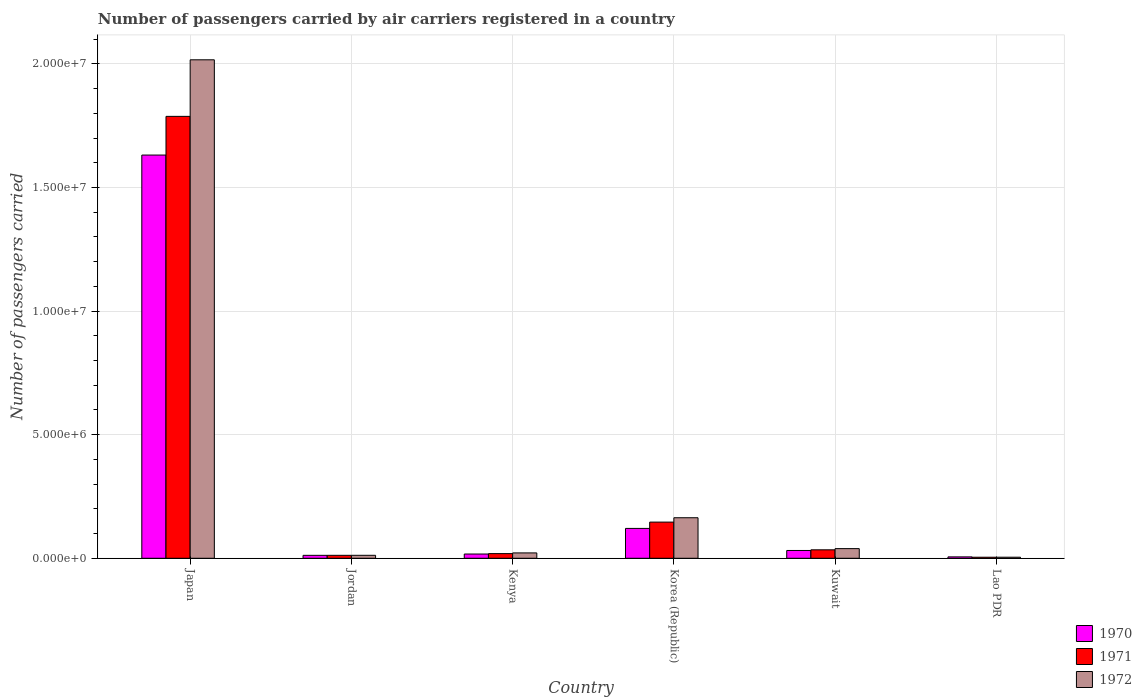How many different coloured bars are there?
Offer a very short reply. 3. How many groups of bars are there?
Provide a short and direct response. 6. Are the number of bars per tick equal to the number of legend labels?
Your response must be concise. Yes. How many bars are there on the 6th tick from the left?
Your answer should be very brief. 3. How many bars are there on the 2nd tick from the right?
Offer a terse response. 3. What is the label of the 4th group of bars from the left?
Ensure brevity in your answer.  Korea (Republic). What is the number of passengers carried by air carriers in 1971 in Lao PDR?
Your answer should be compact. 4.20e+04. Across all countries, what is the maximum number of passengers carried by air carriers in 1971?
Your answer should be compact. 1.79e+07. Across all countries, what is the minimum number of passengers carried by air carriers in 1972?
Make the answer very short. 4.30e+04. In which country was the number of passengers carried by air carriers in 1971 minimum?
Your answer should be very brief. Lao PDR. What is the total number of passengers carried by air carriers in 1972 in the graph?
Offer a terse response. 2.26e+07. What is the difference between the number of passengers carried by air carriers in 1971 in Kenya and that in Kuwait?
Make the answer very short. -1.54e+05. What is the difference between the number of passengers carried by air carriers in 1972 in Jordan and the number of passengers carried by air carriers in 1970 in Korea (Republic)?
Offer a terse response. -1.09e+06. What is the average number of passengers carried by air carriers in 1970 per country?
Provide a short and direct response. 3.03e+06. What is the difference between the number of passengers carried by air carriers of/in 1971 and number of passengers carried by air carriers of/in 1972 in Jordan?
Keep it short and to the point. -300. What is the ratio of the number of passengers carried by air carriers in 1971 in Jordan to that in Kuwait?
Keep it short and to the point. 0.35. What is the difference between the highest and the second highest number of passengers carried by air carriers in 1972?
Offer a terse response. -1.85e+07. What is the difference between the highest and the lowest number of passengers carried by air carriers in 1970?
Ensure brevity in your answer.  1.63e+07. In how many countries, is the number of passengers carried by air carriers in 1970 greater than the average number of passengers carried by air carriers in 1970 taken over all countries?
Give a very brief answer. 1. What does the 3rd bar from the left in Korea (Republic) represents?
Provide a succinct answer. 1972. What does the 2nd bar from the right in Japan represents?
Your response must be concise. 1971. Is it the case that in every country, the sum of the number of passengers carried by air carriers in 1970 and number of passengers carried by air carriers in 1972 is greater than the number of passengers carried by air carriers in 1971?
Offer a very short reply. Yes. Are all the bars in the graph horizontal?
Ensure brevity in your answer.  No. How many countries are there in the graph?
Provide a succinct answer. 6. What is the difference between two consecutive major ticks on the Y-axis?
Provide a short and direct response. 5.00e+06. Are the values on the major ticks of Y-axis written in scientific E-notation?
Offer a very short reply. Yes. Does the graph contain grids?
Make the answer very short. Yes. Where does the legend appear in the graph?
Your answer should be very brief. Bottom right. How many legend labels are there?
Offer a very short reply. 3. What is the title of the graph?
Your response must be concise. Number of passengers carried by air carriers registered in a country. What is the label or title of the X-axis?
Offer a terse response. Country. What is the label or title of the Y-axis?
Give a very brief answer. Number of passengers carried. What is the Number of passengers carried in 1970 in Japan?
Give a very brief answer. 1.63e+07. What is the Number of passengers carried of 1971 in Japan?
Keep it short and to the point. 1.79e+07. What is the Number of passengers carried in 1972 in Japan?
Offer a terse response. 2.02e+07. What is the Number of passengers carried in 1970 in Jordan?
Make the answer very short. 1.19e+05. What is the Number of passengers carried in 1971 in Jordan?
Your answer should be very brief. 1.20e+05. What is the Number of passengers carried of 1972 in Jordan?
Offer a terse response. 1.20e+05. What is the Number of passengers carried in 1970 in Kenya?
Offer a very short reply. 1.72e+05. What is the Number of passengers carried in 1971 in Kenya?
Offer a very short reply. 1.88e+05. What is the Number of passengers carried in 1972 in Kenya?
Your answer should be compact. 2.17e+05. What is the Number of passengers carried of 1970 in Korea (Republic)?
Give a very brief answer. 1.21e+06. What is the Number of passengers carried of 1971 in Korea (Republic)?
Ensure brevity in your answer.  1.46e+06. What is the Number of passengers carried in 1972 in Korea (Republic)?
Ensure brevity in your answer.  1.64e+06. What is the Number of passengers carried of 1970 in Kuwait?
Give a very brief answer. 3.15e+05. What is the Number of passengers carried of 1971 in Kuwait?
Your answer should be compact. 3.42e+05. What is the Number of passengers carried of 1972 in Kuwait?
Offer a terse response. 3.91e+05. What is the Number of passengers carried in 1970 in Lao PDR?
Give a very brief answer. 5.59e+04. What is the Number of passengers carried in 1971 in Lao PDR?
Provide a short and direct response. 4.20e+04. What is the Number of passengers carried of 1972 in Lao PDR?
Give a very brief answer. 4.30e+04. Across all countries, what is the maximum Number of passengers carried of 1970?
Provide a short and direct response. 1.63e+07. Across all countries, what is the maximum Number of passengers carried in 1971?
Ensure brevity in your answer.  1.79e+07. Across all countries, what is the maximum Number of passengers carried in 1972?
Offer a terse response. 2.02e+07. Across all countries, what is the minimum Number of passengers carried of 1970?
Provide a short and direct response. 5.59e+04. Across all countries, what is the minimum Number of passengers carried of 1971?
Provide a succinct answer. 4.20e+04. Across all countries, what is the minimum Number of passengers carried in 1972?
Offer a terse response. 4.30e+04. What is the total Number of passengers carried in 1970 in the graph?
Provide a succinct answer. 1.82e+07. What is the total Number of passengers carried in 1971 in the graph?
Offer a very short reply. 2.00e+07. What is the total Number of passengers carried in 1972 in the graph?
Ensure brevity in your answer.  2.26e+07. What is the difference between the Number of passengers carried of 1970 in Japan and that in Jordan?
Provide a succinct answer. 1.62e+07. What is the difference between the Number of passengers carried of 1971 in Japan and that in Jordan?
Give a very brief answer. 1.78e+07. What is the difference between the Number of passengers carried in 1972 in Japan and that in Jordan?
Ensure brevity in your answer.  2.00e+07. What is the difference between the Number of passengers carried in 1970 in Japan and that in Kenya?
Give a very brief answer. 1.61e+07. What is the difference between the Number of passengers carried of 1971 in Japan and that in Kenya?
Your answer should be compact. 1.77e+07. What is the difference between the Number of passengers carried in 1972 in Japan and that in Kenya?
Ensure brevity in your answer.  2.00e+07. What is the difference between the Number of passengers carried of 1970 in Japan and that in Korea (Republic)?
Make the answer very short. 1.51e+07. What is the difference between the Number of passengers carried in 1971 in Japan and that in Korea (Republic)?
Your answer should be very brief. 1.64e+07. What is the difference between the Number of passengers carried in 1972 in Japan and that in Korea (Republic)?
Make the answer very short. 1.85e+07. What is the difference between the Number of passengers carried of 1970 in Japan and that in Kuwait?
Offer a terse response. 1.60e+07. What is the difference between the Number of passengers carried in 1971 in Japan and that in Kuwait?
Give a very brief answer. 1.75e+07. What is the difference between the Number of passengers carried in 1972 in Japan and that in Kuwait?
Offer a terse response. 1.98e+07. What is the difference between the Number of passengers carried in 1970 in Japan and that in Lao PDR?
Offer a terse response. 1.63e+07. What is the difference between the Number of passengers carried of 1971 in Japan and that in Lao PDR?
Your answer should be very brief. 1.78e+07. What is the difference between the Number of passengers carried in 1972 in Japan and that in Lao PDR?
Your answer should be very brief. 2.01e+07. What is the difference between the Number of passengers carried in 1970 in Jordan and that in Kenya?
Give a very brief answer. -5.27e+04. What is the difference between the Number of passengers carried of 1971 in Jordan and that in Kenya?
Your response must be concise. -6.84e+04. What is the difference between the Number of passengers carried of 1972 in Jordan and that in Kenya?
Your answer should be very brief. -9.69e+04. What is the difference between the Number of passengers carried of 1970 in Jordan and that in Korea (Republic)?
Provide a succinct answer. -1.09e+06. What is the difference between the Number of passengers carried in 1971 in Jordan and that in Korea (Republic)?
Keep it short and to the point. -1.34e+06. What is the difference between the Number of passengers carried in 1972 in Jordan and that in Korea (Republic)?
Provide a succinct answer. -1.52e+06. What is the difference between the Number of passengers carried in 1970 in Jordan and that in Kuwait?
Your answer should be very brief. -1.96e+05. What is the difference between the Number of passengers carried of 1971 in Jordan and that in Kuwait?
Offer a very short reply. -2.23e+05. What is the difference between the Number of passengers carried of 1972 in Jordan and that in Kuwait?
Give a very brief answer. -2.71e+05. What is the difference between the Number of passengers carried of 1970 in Jordan and that in Lao PDR?
Keep it short and to the point. 6.29e+04. What is the difference between the Number of passengers carried in 1971 in Jordan and that in Lao PDR?
Offer a terse response. 7.76e+04. What is the difference between the Number of passengers carried in 1972 in Jordan and that in Lao PDR?
Ensure brevity in your answer.  7.69e+04. What is the difference between the Number of passengers carried of 1970 in Kenya and that in Korea (Republic)?
Your answer should be compact. -1.04e+06. What is the difference between the Number of passengers carried in 1971 in Kenya and that in Korea (Republic)?
Keep it short and to the point. -1.28e+06. What is the difference between the Number of passengers carried in 1972 in Kenya and that in Korea (Republic)?
Provide a short and direct response. -1.42e+06. What is the difference between the Number of passengers carried in 1970 in Kenya and that in Kuwait?
Keep it short and to the point. -1.44e+05. What is the difference between the Number of passengers carried in 1971 in Kenya and that in Kuwait?
Keep it short and to the point. -1.54e+05. What is the difference between the Number of passengers carried of 1972 in Kenya and that in Kuwait?
Ensure brevity in your answer.  -1.74e+05. What is the difference between the Number of passengers carried of 1970 in Kenya and that in Lao PDR?
Give a very brief answer. 1.16e+05. What is the difference between the Number of passengers carried in 1971 in Kenya and that in Lao PDR?
Offer a very short reply. 1.46e+05. What is the difference between the Number of passengers carried in 1972 in Kenya and that in Lao PDR?
Your answer should be compact. 1.74e+05. What is the difference between the Number of passengers carried of 1970 in Korea (Republic) and that in Kuwait?
Provide a succinct answer. 8.93e+05. What is the difference between the Number of passengers carried of 1971 in Korea (Republic) and that in Kuwait?
Make the answer very short. 1.12e+06. What is the difference between the Number of passengers carried of 1972 in Korea (Republic) and that in Kuwait?
Give a very brief answer. 1.25e+06. What is the difference between the Number of passengers carried in 1970 in Korea (Republic) and that in Lao PDR?
Your answer should be very brief. 1.15e+06. What is the difference between the Number of passengers carried of 1971 in Korea (Republic) and that in Lao PDR?
Provide a short and direct response. 1.42e+06. What is the difference between the Number of passengers carried of 1972 in Korea (Republic) and that in Lao PDR?
Your response must be concise. 1.60e+06. What is the difference between the Number of passengers carried of 1970 in Kuwait and that in Lao PDR?
Offer a terse response. 2.59e+05. What is the difference between the Number of passengers carried of 1971 in Kuwait and that in Lao PDR?
Keep it short and to the point. 3.00e+05. What is the difference between the Number of passengers carried of 1972 in Kuwait and that in Lao PDR?
Your answer should be very brief. 3.48e+05. What is the difference between the Number of passengers carried in 1970 in Japan and the Number of passengers carried in 1971 in Jordan?
Your answer should be very brief. 1.62e+07. What is the difference between the Number of passengers carried in 1970 in Japan and the Number of passengers carried in 1972 in Jordan?
Provide a succinct answer. 1.62e+07. What is the difference between the Number of passengers carried in 1971 in Japan and the Number of passengers carried in 1972 in Jordan?
Your answer should be compact. 1.78e+07. What is the difference between the Number of passengers carried of 1970 in Japan and the Number of passengers carried of 1971 in Kenya?
Ensure brevity in your answer.  1.61e+07. What is the difference between the Number of passengers carried in 1970 in Japan and the Number of passengers carried in 1972 in Kenya?
Provide a short and direct response. 1.61e+07. What is the difference between the Number of passengers carried of 1971 in Japan and the Number of passengers carried of 1972 in Kenya?
Your answer should be very brief. 1.77e+07. What is the difference between the Number of passengers carried in 1970 in Japan and the Number of passengers carried in 1971 in Korea (Republic)?
Keep it short and to the point. 1.49e+07. What is the difference between the Number of passengers carried of 1970 in Japan and the Number of passengers carried of 1972 in Korea (Republic)?
Offer a terse response. 1.47e+07. What is the difference between the Number of passengers carried in 1971 in Japan and the Number of passengers carried in 1972 in Korea (Republic)?
Offer a very short reply. 1.62e+07. What is the difference between the Number of passengers carried in 1970 in Japan and the Number of passengers carried in 1971 in Kuwait?
Provide a succinct answer. 1.60e+07. What is the difference between the Number of passengers carried of 1970 in Japan and the Number of passengers carried of 1972 in Kuwait?
Your answer should be very brief. 1.59e+07. What is the difference between the Number of passengers carried in 1971 in Japan and the Number of passengers carried in 1972 in Kuwait?
Your response must be concise. 1.75e+07. What is the difference between the Number of passengers carried of 1970 in Japan and the Number of passengers carried of 1971 in Lao PDR?
Your answer should be very brief. 1.63e+07. What is the difference between the Number of passengers carried in 1970 in Japan and the Number of passengers carried in 1972 in Lao PDR?
Your answer should be very brief. 1.63e+07. What is the difference between the Number of passengers carried of 1971 in Japan and the Number of passengers carried of 1972 in Lao PDR?
Keep it short and to the point. 1.78e+07. What is the difference between the Number of passengers carried of 1970 in Jordan and the Number of passengers carried of 1971 in Kenya?
Provide a short and direct response. -6.92e+04. What is the difference between the Number of passengers carried in 1970 in Jordan and the Number of passengers carried in 1972 in Kenya?
Your response must be concise. -9.80e+04. What is the difference between the Number of passengers carried in 1971 in Jordan and the Number of passengers carried in 1972 in Kenya?
Provide a short and direct response. -9.72e+04. What is the difference between the Number of passengers carried in 1970 in Jordan and the Number of passengers carried in 1971 in Korea (Republic)?
Give a very brief answer. -1.34e+06. What is the difference between the Number of passengers carried in 1970 in Jordan and the Number of passengers carried in 1972 in Korea (Republic)?
Make the answer very short. -1.52e+06. What is the difference between the Number of passengers carried of 1971 in Jordan and the Number of passengers carried of 1972 in Korea (Republic)?
Make the answer very short. -1.52e+06. What is the difference between the Number of passengers carried of 1970 in Jordan and the Number of passengers carried of 1971 in Kuwait?
Ensure brevity in your answer.  -2.23e+05. What is the difference between the Number of passengers carried in 1970 in Jordan and the Number of passengers carried in 1972 in Kuwait?
Provide a succinct answer. -2.72e+05. What is the difference between the Number of passengers carried in 1971 in Jordan and the Number of passengers carried in 1972 in Kuwait?
Your response must be concise. -2.71e+05. What is the difference between the Number of passengers carried of 1970 in Jordan and the Number of passengers carried of 1971 in Lao PDR?
Keep it short and to the point. 7.68e+04. What is the difference between the Number of passengers carried in 1970 in Jordan and the Number of passengers carried in 1972 in Lao PDR?
Provide a short and direct response. 7.58e+04. What is the difference between the Number of passengers carried of 1971 in Jordan and the Number of passengers carried of 1972 in Lao PDR?
Provide a short and direct response. 7.66e+04. What is the difference between the Number of passengers carried of 1970 in Kenya and the Number of passengers carried of 1971 in Korea (Republic)?
Offer a terse response. -1.29e+06. What is the difference between the Number of passengers carried in 1970 in Kenya and the Number of passengers carried in 1972 in Korea (Republic)?
Provide a succinct answer. -1.47e+06. What is the difference between the Number of passengers carried in 1971 in Kenya and the Number of passengers carried in 1972 in Korea (Republic)?
Provide a short and direct response. -1.45e+06. What is the difference between the Number of passengers carried of 1970 in Kenya and the Number of passengers carried of 1971 in Kuwait?
Make the answer very short. -1.71e+05. What is the difference between the Number of passengers carried in 1970 in Kenya and the Number of passengers carried in 1972 in Kuwait?
Make the answer very short. -2.19e+05. What is the difference between the Number of passengers carried of 1971 in Kenya and the Number of passengers carried of 1972 in Kuwait?
Give a very brief answer. -2.03e+05. What is the difference between the Number of passengers carried in 1970 in Kenya and the Number of passengers carried in 1971 in Lao PDR?
Provide a short and direct response. 1.30e+05. What is the difference between the Number of passengers carried in 1970 in Kenya and the Number of passengers carried in 1972 in Lao PDR?
Provide a succinct answer. 1.28e+05. What is the difference between the Number of passengers carried of 1971 in Kenya and the Number of passengers carried of 1972 in Lao PDR?
Provide a short and direct response. 1.45e+05. What is the difference between the Number of passengers carried in 1970 in Korea (Republic) and the Number of passengers carried in 1971 in Kuwait?
Offer a very short reply. 8.66e+05. What is the difference between the Number of passengers carried in 1970 in Korea (Republic) and the Number of passengers carried in 1972 in Kuwait?
Your response must be concise. 8.17e+05. What is the difference between the Number of passengers carried in 1971 in Korea (Republic) and the Number of passengers carried in 1972 in Kuwait?
Offer a terse response. 1.07e+06. What is the difference between the Number of passengers carried in 1970 in Korea (Republic) and the Number of passengers carried in 1971 in Lao PDR?
Your answer should be compact. 1.17e+06. What is the difference between the Number of passengers carried in 1970 in Korea (Republic) and the Number of passengers carried in 1972 in Lao PDR?
Keep it short and to the point. 1.17e+06. What is the difference between the Number of passengers carried of 1971 in Korea (Republic) and the Number of passengers carried of 1972 in Lao PDR?
Keep it short and to the point. 1.42e+06. What is the difference between the Number of passengers carried of 1970 in Kuwait and the Number of passengers carried of 1971 in Lao PDR?
Make the answer very short. 2.73e+05. What is the difference between the Number of passengers carried of 1970 in Kuwait and the Number of passengers carried of 1972 in Lao PDR?
Provide a succinct answer. 2.72e+05. What is the difference between the Number of passengers carried in 1971 in Kuwait and the Number of passengers carried in 1972 in Lao PDR?
Provide a short and direct response. 2.99e+05. What is the average Number of passengers carried of 1970 per country?
Offer a terse response. 3.03e+06. What is the average Number of passengers carried of 1971 per country?
Provide a succinct answer. 3.34e+06. What is the average Number of passengers carried of 1972 per country?
Your answer should be compact. 3.76e+06. What is the difference between the Number of passengers carried in 1970 and Number of passengers carried in 1971 in Japan?
Provide a succinct answer. -1.57e+06. What is the difference between the Number of passengers carried in 1970 and Number of passengers carried in 1972 in Japan?
Keep it short and to the point. -3.85e+06. What is the difference between the Number of passengers carried of 1971 and Number of passengers carried of 1972 in Japan?
Your answer should be compact. -2.29e+06. What is the difference between the Number of passengers carried in 1970 and Number of passengers carried in 1971 in Jordan?
Give a very brief answer. -800. What is the difference between the Number of passengers carried in 1970 and Number of passengers carried in 1972 in Jordan?
Ensure brevity in your answer.  -1100. What is the difference between the Number of passengers carried in 1971 and Number of passengers carried in 1972 in Jordan?
Ensure brevity in your answer.  -300. What is the difference between the Number of passengers carried of 1970 and Number of passengers carried of 1971 in Kenya?
Provide a succinct answer. -1.65e+04. What is the difference between the Number of passengers carried in 1970 and Number of passengers carried in 1972 in Kenya?
Offer a very short reply. -4.53e+04. What is the difference between the Number of passengers carried in 1971 and Number of passengers carried in 1972 in Kenya?
Your answer should be very brief. -2.88e+04. What is the difference between the Number of passengers carried of 1970 and Number of passengers carried of 1971 in Korea (Republic)?
Provide a succinct answer. -2.56e+05. What is the difference between the Number of passengers carried in 1970 and Number of passengers carried in 1972 in Korea (Republic)?
Ensure brevity in your answer.  -4.32e+05. What is the difference between the Number of passengers carried of 1971 and Number of passengers carried of 1972 in Korea (Republic)?
Provide a succinct answer. -1.76e+05. What is the difference between the Number of passengers carried of 1970 and Number of passengers carried of 1971 in Kuwait?
Your answer should be very brief. -2.70e+04. What is the difference between the Number of passengers carried in 1970 and Number of passengers carried in 1972 in Kuwait?
Ensure brevity in your answer.  -7.55e+04. What is the difference between the Number of passengers carried in 1971 and Number of passengers carried in 1972 in Kuwait?
Provide a short and direct response. -4.85e+04. What is the difference between the Number of passengers carried of 1970 and Number of passengers carried of 1971 in Lao PDR?
Provide a short and direct response. 1.39e+04. What is the difference between the Number of passengers carried of 1970 and Number of passengers carried of 1972 in Lao PDR?
Offer a very short reply. 1.29e+04. What is the difference between the Number of passengers carried of 1971 and Number of passengers carried of 1972 in Lao PDR?
Make the answer very short. -1000. What is the ratio of the Number of passengers carried in 1970 in Japan to that in Jordan?
Provide a short and direct response. 137.33. What is the ratio of the Number of passengers carried of 1971 in Japan to that in Jordan?
Ensure brevity in your answer.  149.5. What is the ratio of the Number of passengers carried in 1972 in Japan to that in Jordan?
Ensure brevity in your answer.  168.22. What is the ratio of the Number of passengers carried in 1970 in Japan to that in Kenya?
Ensure brevity in your answer.  95.13. What is the ratio of the Number of passengers carried of 1971 in Japan to that in Kenya?
Offer a terse response. 95.11. What is the ratio of the Number of passengers carried in 1972 in Japan to that in Kenya?
Provide a short and direct response. 93.03. What is the ratio of the Number of passengers carried of 1970 in Japan to that in Korea (Republic)?
Your response must be concise. 13.5. What is the ratio of the Number of passengers carried of 1971 in Japan to that in Korea (Republic)?
Ensure brevity in your answer.  12.22. What is the ratio of the Number of passengers carried in 1972 in Japan to that in Korea (Republic)?
Your answer should be very brief. 12.3. What is the ratio of the Number of passengers carried in 1970 in Japan to that in Kuwait?
Provide a succinct answer. 51.76. What is the ratio of the Number of passengers carried in 1971 in Japan to that in Kuwait?
Make the answer very short. 52.25. What is the ratio of the Number of passengers carried in 1972 in Japan to that in Kuwait?
Your answer should be compact. 51.62. What is the ratio of the Number of passengers carried of 1970 in Japan to that in Lao PDR?
Your answer should be compact. 291.86. What is the ratio of the Number of passengers carried of 1971 in Japan to that in Lao PDR?
Your answer should be compact. 425.73. What is the ratio of the Number of passengers carried in 1972 in Japan to that in Lao PDR?
Give a very brief answer. 469.06. What is the ratio of the Number of passengers carried of 1970 in Jordan to that in Kenya?
Your answer should be compact. 0.69. What is the ratio of the Number of passengers carried of 1971 in Jordan to that in Kenya?
Offer a terse response. 0.64. What is the ratio of the Number of passengers carried of 1972 in Jordan to that in Kenya?
Keep it short and to the point. 0.55. What is the ratio of the Number of passengers carried in 1970 in Jordan to that in Korea (Republic)?
Your response must be concise. 0.1. What is the ratio of the Number of passengers carried of 1971 in Jordan to that in Korea (Republic)?
Your answer should be compact. 0.08. What is the ratio of the Number of passengers carried in 1972 in Jordan to that in Korea (Republic)?
Provide a succinct answer. 0.07. What is the ratio of the Number of passengers carried of 1970 in Jordan to that in Kuwait?
Provide a succinct answer. 0.38. What is the ratio of the Number of passengers carried in 1971 in Jordan to that in Kuwait?
Provide a short and direct response. 0.35. What is the ratio of the Number of passengers carried of 1972 in Jordan to that in Kuwait?
Your response must be concise. 0.31. What is the ratio of the Number of passengers carried in 1970 in Jordan to that in Lao PDR?
Offer a terse response. 2.13. What is the ratio of the Number of passengers carried of 1971 in Jordan to that in Lao PDR?
Provide a short and direct response. 2.85. What is the ratio of the Number of passengers carried in 1972 in Jordan to that in Lao PDR?
Make the answer very short. 2.79. What is the ratio of the Number of passengers carried of 1970 in Kenya to that in Korea (Republic)?
Your response must be concise. 0.14. What is the ratio of the Number of passengers carried of 1971 in Kenya to that in Korea (Republic)?
Your response must be concise. 0.13. What is the ratio of the Number of passengers carried in 1972 in Kenya to that in Korea (Republic)?
Make the answer very short. 0.13. What is the ratio of the Number of passengers carried of 1970 in Kenya to that in Kuwait?
Offer a terse response. 0.54. What is the ratio of the Number of passengers carried of 1971 in Kenya to that in Kuwait?
Offer a very short reply. 0.55. What is the ratio of the Number of passengers carried in 1972 in Kenya to that in Kuwait?
Your response must be concise. 0.55. What is the ratio of the Number of passengers carried in 1970 in Kenya to that in Lao PDR?
Your answer should be very brief. 3.07. What is the ratio of the Number of passengers carried in 1971 in Kenya to that in Lao PDR?
Offer a very short reply. 4.48. What is the ratio of the Number of passengers carried of 1972 in Kenya to that in Lao PDR?
Offer a terse response. 5.04. What is the ratio of the Number of passengers carried in 1970 in Korea (Republic) to that in Kuwait?
Provide a succinct answer. 3.83. What is the ratio of the Number of passengers carried of 1971 in Korea (Republic) to that in Kuwait?
Give a very brief answer. 4.28. What is the ratio of the Number of passengers carried in 1972 in Korea (Republic) to that in Kuwait?
Give a very brief answer. 4.2. What is the ratio of the Number of passengers carried in 1970 in Korea (Republic) to that in Lao PDR?
Ensure brevity in your answer.  21.61. What is the ratio of the Number of passengers carried of 1971 in Korea (Republic) to that in Lao PDR?
Provide a short and direct response. 34.85. What is the ratio of the Number of passengers carried in 1972 in Korea (Republic) to that in Lao PDR?
Keep it short and to the point. 38.14. What is the ratio of the Number of passengers carried of 1970 in Kuwait to that in Lao PDR?
Keep it short and to the point. 5.64. What is the ratio of the Number of passengers carried of 1971 in Kuwait to that in Lao PDR?
Keep it short and to the point. 8.15. What is the ratio of the Number of passengers carried of 1972 in Kuwait to that in Lao PDR?
Your response must be concise. 9.09. What is the difference between the highest and the second highest Number of passengers carried in 1970?
Provide a short and direct response. 1.51e+07. What is the difference between the highest and the second highest Number of passengers carried in 1971?
Make the answer very short. 1.64e+07. What is the difference between the highest and the second highest Number of passengers carried in 1972?
Make the answer very short. 1.85e+07. What is the difference between the highest and the lowest Number of passengers carried of 1970?
Offer a very short reply. 1.63e+07. What is the difference between the highest and the lowest Number of passengers carried in 1971?
Give a very brief answer. 1.78e+07. What is the difference between the highest and the lowest Number of passengers carried of 1972?
Your response must be concise. 2.01e+07. 